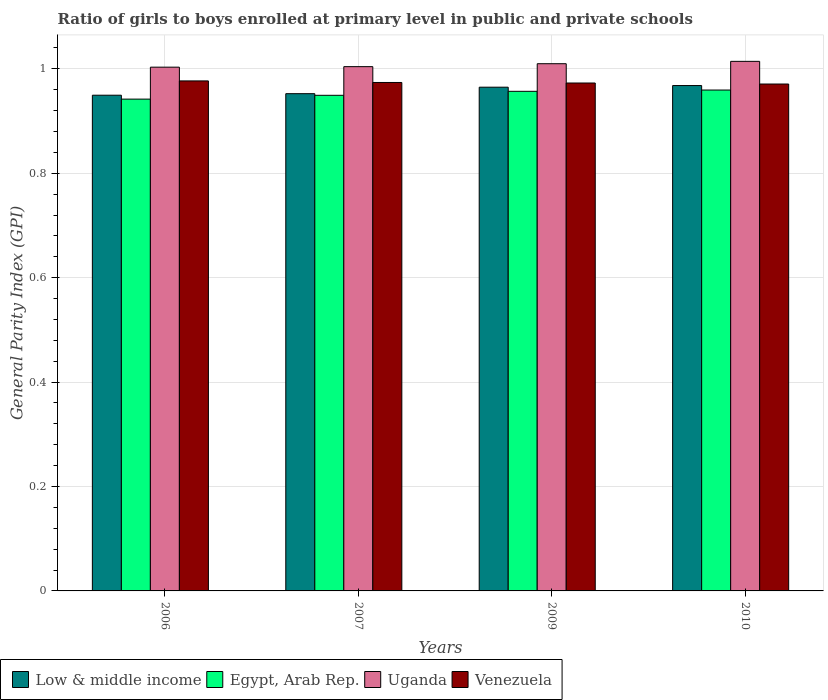How many different coloured bars are there?
Your answer should be compact. 4. Are the number of bars per tick equal to the number of legend labels?
Offer a terse response. Yes. What is the label of the 2nd group of bars from the left?
Offer a very short reply. 2007. What is the general parity index in Egypt, Arab Rep. in 2006?
Keep it short and to the point. 0.94. Across all years, what is the maximum general parity index in Egypt, Arab Rep.?
Ensure brevity in your answer.  0.96. Across all years, what is the minimum general parity index in Venezuela?
Ensure brevity in your answer.  0.97. In which year was the general parity index in Uganda maximum?
Offer a very short reply. 2010. What is the total general parity index in Venezuela in the graph?
Provide a short and direct response. 3.89. What is the difference between the general parity index in Venezuela in 2009 and that in 2010?
Give a very brief answer. 0. What is the difference between the general parity index in Low & middle income in 2010 and the general parity index in Egypt, Arab Rep. in 2006?
Provide a short and direct response. 0.03. What is the average general parity index in Venezuela per year?
Offer a terse response. 0.97. In the year 2010, what is the difference between the general parity index in Low & middle income and general parity index in Uganda?
Your answer should be very brief. -0.05. What is the ratio of the general parity index in Egypt, Arab Rep. in 2007 to that in 2010?
Your answer should be compact. 0.99. Is the general parity index in Low & middle income in 2009 less than that in 2010?
Your response must be concise. Yes. Is the difference between the general parity index in Low & middle income in 2006 and 2010 greater than the difference between the general parity index in Uganda in 2006 and 2010?
Provide a short and direct response. No. What is the difference between the highest and the second highest general parity index in Low & middle income?
Offer a terse response. 0. What is the difference between the highest and the lowest general parity index in Venezuela?
Make the answer very short. 0.01. In how many years, is the general parity index in Egypt, Arab Rep. greater than the average general parity index in Egypt, Arab Rep. taken over all years?
Ensure brevity in your answer.  2. What does the 4th bar from the left in 2006 represents?
Offer a terse response. Venezuela. What does the 2nd bar from the right in 2009 represents?
Your response must be concise. Uganda. How many bars are there?
Make the answer very short. 16. How many years are there in the graph?
Your answer should be compact. 4. What is the difference between two consecutive major ticks on the Y-axis?
Your response must be concise. 0.2. Are the values on the major ticks of Y-axis written in scientific E-notation?
Make the answer very short. No. How many legend labels are there?
Give a very brief answer. 4. What is the title of the graph?
Your response must be concise. Ratio of girls to boys enrolled at primary level in public and private schools. Does "Europe(all income levels)" appear as one of the legend labels in the graph?
Keep it short and to the point. No. What is the label or title of the Y-axis?
Make the answer very short. General Parity Index (GPI). What is the General Parity Index (GPI) in Low & middle income in 2006?
Offer a very short reply. 0.95. What is the General Parity Index (GPI) in Egypt, Arab Rep. in 2006?
Ensure brevity in your answer.  0.94. What is the General Parity Index (GPI) of Uganda in 2006?
Offer a terse response. 1. What is the General Parity Index (GPI) in Venezuela in 2006?
Your answer should be very brief. 0.98. What is the General Parity Index (GPI) of Low & middle income in 2007?
Offer a very short reply. 0.95. What is the General Parity Index (GPI) in Egypt, Arab Rep. in 2007?
Offer a terse response. 0.95. What is the General Parity Index (GPI) in Uganda in 2007?
Ensure brevity in your answer.  1. What is the General Parity Index (GPI) in Venezuela in 2007?
Give a very brief answer. 0.97. What is the General Parity Index (GPI) of Low & middle income in 2009?
Give a very brief answer. 0.96. What is the General Parity Index (GPI) of Egypt, Arab Rep. in 2009?
Your answer should be compact. 0.96. What is the General Parity Index (GPI) in Uganda in 2009?
Your response must be concise. 1.01. What is the General Parity Index (GPI) in Venezuela in 2009?
Make the answer very short. 0.97. What is the General Parity Index (GPI) in Low & middle income in 2010?
Give a very brief answer. 0.97. What is the General Parity Index (GPI) of Egypt, Arab Rep. in 2010?
Offer a very short reply. 0.96. What is the General Parity Index (GPI) in Uganda in 2010?
Provide a succinct answer. 1.01. What is the General Parity Index (GPI) in Venezuela in 2010?
Provide a succinct answer. 0.97. Across all years, what is the maximum General Parity Index (GPI) in Low & middle income?
Ensure brevity in your answer.  0.97. Across all years, what is the maximum General Parity Index (GPI) in Egypt, Arab Rep.?
Offer a terse response. 0.96. Across all years, what is the maximum General Parity Index (GPI) in Uganda?
Your answer should be compact. 1.01. Across all years, what is the maximum General Parity Index (GPI) of Venezuela?
Offer a very short reply. 0.98. Across all years, what is the minimum General Parity Index (GPI) in Low & middle income?
Provide a short and direct response. 0.95. Across all years, what is the minimum General Parity Index (GPI) of Egypt, Arab Rep.?
Offer a terse response. 0.94. Across all years, what is the minimum General Parity Index (GPI) of Uganda?
Give a very brief answer. 1. Across all years, what is the minimum General Parity Index (GPI) in Venezuela?
Make the answer very short. 0.97. What is the total General Parity Index (GPI) in Low & middle income in the graph?
Provide a succinct answer. 3.83. What is the total General Parity Index (GPI) of Egypt, Arab Rep. in the graph?
Keep it short and to the point. 3.81. What is the total General Parity Index (GPI) in Uganda in the graph?
Ensure brevity in your answer.  4.03. What is the total General Parity Index (GPI) of Venezuela in the graph?
Keep it short and to the point. 3.89. What is the difference between the General Parity Index (GPI) of Low & middle income in 2006 and that in 2007?
Ensure brevity in your answer.  -0. What is the difference between the General Parity Index (GPI) of Egypt, Arab Rep. in 2006 and that in 2007?
Your answer should be very brief. -0.01. What is the difference between the General Parity Index (GPI) in Uganda in 2006 and that in 2007?
Keep it short and to the point. -0. What is the difference between the General Parity Index (GPI) of Venezuela in 2006 and that in 2007?
Make the answer very short. 0. What is the difference between the General Parity Index (GPI) of Low & middle income in 2006 and that in 2009?
Make the answer very short. -0.02. What is the difference between the General Parity Index (GPI) of Egypt, Arab Rep. in 2006 and that in 2009?
Make the answer very short. -0.01. What is the difference between the General Parity Index (GPI) in Uganda in 2006 and that in 2009?
Your answer should be compact. -0.01. What is the difference between the General Parity Index (GPI) of Venezuela in 2006 and that in 2009?
Your answer should be very brief. 0. What is the difference between the General Parity Index (GPI) in Low & middle income in 2006 and that in 2010?
Ensure brevity in your answer.  -0.02. What is the difference between the General Parity Index (GPI) of Egypt, Arab Rep. in 2006 and that in 2010?
Provide a succinct answer. -0.02. What is the difference between the General Parity Index (GPI) in Uganda in 2006 and that in 2010?
Provide a succinct answer. -0.01. What is the difference between the General Parity Index (GPI) of Venezuela in 2006 and that in 2010?
Provide a short and direct response. 0.01. What is the difference between the General Parity Index (GPI) in Low & middle income in 2007 and that in 2009?
Make the answer very short. -0.01. What is the difference between the General Parity Index (GPI) in Egypt, Arab Rep. in 2007 and that in 2009?
Your answer should be compact. -0.01. What is the difference between the General Parity Index (GPI) in Uganda in 2007 and that in 2009?
Offer a terse response. -0.01. What is the difference between the General Parity Index (GPI) in Low & middle income in 2007 and that in 2010?
Your answer should be compact. -0.02. What is the difference between the General Parity Index (GPI) of Egypt, Arab Rep. in 2007 and that in 2010?
Offer a very short reply. -0.01. What is the difference between the General Parity Index (GPI) in Uganda in 2007 and that in 2010?
Keep it short and to the point. -0.01. What is the difference between the General Parity Index (GPI) in Venezuela in 2007 and that in 2010?
Provide a succinct answer. 0. What is the difference between the General Parity Index (GPI) of Low & middle income in 2009 and that in 2010?
Provide a succinct answer. -0. What is the difference between the General Parity Index (GPI) in Egypt, Arab Rep. in 2009 and that in 2010?
Make the answer very short. -0. What is the difference between the General Parity Index (GPI) of Uganda in 2009 and that in 2010?
Offer a very short reply. -0. What is the difference between the General Parity Index (GPI) of Venezuela in 2009 and that in 2010?
Offer a very short reply. 0. What is the difference between the General Parity Index (GPI) of Low & middle income in 2006 and the General Parity Index (GPI) of Uganda in 2007?
Offer a terse response. -0.05. What is the difference between the General Parity Index (GPI) of Low & middle income in 2006 and the General Parity Index (GPI) of Venezuela in 2007?
Offer a terse response. -0.02. What is the difference between the General Parity Index (GPI) of Egypt, Arab Rep. in 2006 and the General Parity Index (GPI) of Uganda in 2007?
Make the answer very short. -0.06. What is the difference between the General Parity Index (GPI) in Egypt, Arab Rep. in 2006 and the General Parity Index (GPI) in Venezuela in 2007?
Provide a short and direct response. -0.03. What is the difference between the General Parity Index (GPI) in Uganda in 2006 and the General Parity Index (GPI) in Venezuela in 2007?
Offer a terse response. 0.03. What is the difference between the General Parity Index (GPI) in Low & middle income in 2006 and the General Parity Index (GPI) in Egypt, Arab Rep. in 2009?
Your response must be concise. -0.01. What is the difference between the General Parity Index (GPI) of Low & middle income in 2006 and the General Parity Index (GPI) of Uganda in 2009?
Offer a very short reply. -0.06. What is the difference between the General Parity Index (GPI) of Low & middle income in 2006 and the General Parity Index (GPI) of Venezuela in 2009?
Offer a very short reply. -0.02. What is the difference between the General Parity Index (GPI) in Egypt, Arab Rep. in 2006 and the General Parity Index (GPI) in Uganda in 2009?
Give a very brief answer. -0.07. What is the difference between the General Parity Index (GPI) of Egypt, Arab Rep. in 2006 and the General Parity Index (GPI) of Venezuela in 2009?
Provide a short and direct response. -0.03. What is the difference between the General Parity Index (GPI) of Uganda in 2006 and the General Parity Index (GPI) of Venezuela in 2009?
Your response must be concise. 0.03. What is the difference between the General Parity Index (GPI) in Low & middle income in 2006 and the General Parity Index (GPI) in Egypt, Arab Rep. in 2010?
Your answer should be compact. -0.01. What is the difference between the General Parity Index (GPI) in Low & middle income in 2006 and the General Parity Index (GPI) in Uganda in 2010?
Your answer should be compact. -0.06. What is the difference between the General Parity Index (GPI) of Low & middle income in 2006 and the General Parity Index (GPI) of Venezuela in 2010?
Make the answer very short. -0.02. What is the difference between the General Parity Index (GPI) in Egypt, Arab Rep. in 2006 and the General Parity Index (GPI) in Uganda in 2010?
Your answer should be very brief. -0.07. What is the difference between the General Parity Index (GPI) in Egypt, Arab Rep. in 2006 and the General Parity Index (GPI) in Venezuela in 2010?
Provide a succinct answer. -0.03. What is the difference between the General Parity Index (GPI) in Uganda in 2006 and the General Parity Index (GPI) in Venezuela in 2010?
Provide a succinct answer. 0.03. What is the difference between the General Parity Index (GPI) of Low & middle income in 2007 and the General Parity Index (GPI) of Egypt, Arab Rep. in 2009?
Give a very brief answer. -0. What is the difference between the General Parity Index (GPI) of Low & middle income in 2007 and the General Parity Index (GPI) of Uganda in 2009?
Your response must be concise. -0.06. What is the difference between the General Parity Index (GPI) of Low & middle income in 2007 and the General Parity Index (GPI) of Venezuela in 2009?
Offer a very short reply. -0.02. What is the difference between the General Parity Index (GPI) of Egypt, Arab Rep. in 2007 and the General Parity Index (GPI) of Uganda in 2009?
Offer a very short reply. -0.06. What is the difference between the General Parity Index (GPI) of Egypt, Arab Rep. in 2007 and the General Parity Index (GPI) of Venezuela in 2009?
Offer a very short reply. -0.02. What is the difference between the General Parity Index (GPI) in Uganda in 2007 and the General Parity Index (GPI) in Venezuela in 2009?
Make the answer very short. 0.03. What is the difference between the General Parity Index (GPI) of Low & middle income in 2007 and the General Parity Index (GPI) of Egypt, Arab Rep. in 2010?
Your answer should be very brief. -0.01. What is the difference between the General Parity Index (GPI) in Low & middle income in 2007 and the General Parity Index (GPI) in Uganda in 2010?
Give a very brief answer. -0.06. What is the difference between the General Parity Index (GPI) of Low & middle income in 2007 and the General Parity Index (GPI) of Venezuela in 2010?
Make the answer very short. -0.02. What is the difference between the General Parity Index (GPI) of Egypt, Arab Rep. in 2007 and the General Parity Index (GPI) of Uganda in 2010?
Your answer should be very brief. -0.07. What is the difference between the General Parity Index (GPI) in Egypt, Arab Rep. in 2007 and the General Parity Index (GPI) in Venezuela in 2010?
Your answer should be compact. -0.02. What is the difference between the General Parity Index (GPI) of Low & middle income in 2009 and the General Parity Index (GPI) of Egypt, Arab Rep. in 2010?
Provide a succinct answer. 0.01. What is the difference between the General Parity Index (GPI) of Low & middle income in 2009 and the General Parity Index (GPI) of Uganda in 2010?
Offer a very short reply. -0.05. What is the difference between the General Parity Index (GPI) of Low & middle income in 2009 and the General Parity Index (GPI) of Venezuela in 2010?
Provide a succinct answer. -0.01. What is the difference between the General Parity Index (GPI) in Egypt, Arab Rep. in 2009 and the General Parity Index (GPI) in Uganda in 2010?
Keep it short and to the point. -0.06. What is the difference between the General Parity Index (GPI) of Egypt, Arab Rep. in 2009 and the General Parity Index (GPI) of Venezuela in 2010?
Your answer should be very brief. -0.01. What is the difference between the General Parity Index (GPI) in Uganda in 2009 and the General Parity Index (GPI) in Venezuela in 2010?
Make the answer very short. 0.04. What is the average General Parity Index (GPI) in Low & middle income per year?
Give a very brief answer. 0.96. What is the average General Parity Index (GPI) of Egypt, Arab Rep. per year?
Give a very brief answer. 0.95. What is the average General Parity Index (GPI) of Uganda per year?
Your answer should be very brief. 1.01. What is the average General Parity Index (GPI) of Venezuela per year?
Offer a very short reply. 0.97. In the year 2006, what is the difference between the General Parity Index (GPI) of Low & middle income and General Parity Index (GPI) of Egypt, Arab Rep.?
Give a very brief answer. 0.01. In the year 2006, what is the difference between the General Parity Index (GPI) of Low & middle income and General Parity Index (GPI) of Uganda?
Provide a short and direct response. -0.05. In the year 2006, what is the difference between the General Parity Index (GPI) in Low & middle income and General Parity Index (GPI) in Venezuela?
Your answer should be very brief. -0.03. In the year 2006, what is the difference between the General Parity Index (GPI) in Egypt, Arab Rep. and General Parity Index (GPI) in Uganda?
Ensure brevity in your answer.  -0.06. In the year 2006, what is the difference between the General Parity Index (GPI) in Egypt, Arab Rep. and General Parity Index (GPI) in Venezuela?
Provide a succinct answer. -0.03. In the year 2006, what is the difference between the General Parity Index (GPI) of Uganda and General Parity Index (GPI) of Venezuela?
Keep it short and to the point. 0.03. In the year 2007, what is the difference between the General Parity Index (GPI) of Low & middle income and General Parity Index (GPI) of Egypt, Arab Rep.?
Offer a terse response. 0. In the year 2007, what is the difference between the General Parity Index (GPI) in Low & middle income and General Parity Index (GPI) in Uganda?
Provide a succinct answer. -0.05. In the year 2007, what is the difference between the General Parity Index (GPI) in Low & middle income and General Parity Index (GPI) in Venezuela?
Your response must be concise. -0.02. In the year 2007, what is the difference between the General Parity Index (GPI) in Egypt, Arab Rep. and General Parity Index (GPI) in Uganda?
Keep it short and to the point. -0.05. In the year 2007, what is the difference between the General Parity Index (GPI) in Egypt, Arab Rep. and General Parity Index (GPI) in Venezuela?
Your response must be concise. -0.02. In the year 2007, what is the difference between the General Parity Index (GPI) of Uganda and General Parity Index (GPI) of Venezuela?
Offer a terse response. 0.03. In the year 2009, what is the difference between the General Parity Index (GPI) of Low & middle income and General Parity Index (GPI) of Egypt, Arab Rep.?
Keep it short and to the point. 0.01. In the year 2009, what is the difference between the General Parity Index (GPI) of Low & middle income and General Parity Index (GPI) of Uganda?
Offer a terse response. -0.04. In the year 2009, what is the difference between the General Parity Index (GPI) in Low & middle income and General Parity Index (GPI) in Venezuela?
Give a very brief answer. -0.01. In the year 2009, what is the difference between the General Parity Index (GPI) in Egypt, Arab Rep. and General Parity Index (GPI) in Uganda?
Your answer should be compact. -0.05. In the year 2009, what is the difference between the General Parity Index (GPI) in Egypt, Arab Rep. and General Parity Index (GPI) in Venezuela?
Offer a very short reply. -0.02. In the year 2009, what is the difference between the General Parity Index (GPI) in Uganda and General Parity Index (GPI) in Venezuela?
Keep it short and to the point. 0.04. In the year 2010, what is the difference between the General Parity Index (GPI) in Low & middle income and General Parity Index (GPI) in Egypt, Arab Rep.?
Provide a succinct answer. 0.01. In the year 2010, what is the difference between the General Parity Index (GPI) of Low & middle income and General Parity Index (GPI) of Uganda?
Your response must be concise. -0.05. In the year 2010, what is the difference between the General Parity Index (GPI) of Low & middle income and General Parity Index (GPI) of Venezuela?
Provide a short and direct response. -0. In the year 2010, what is the difference between the General Parity Index (GPI) in Egypt, Arab Rep. and General Parity Index (GPI) in Uganda?
Keep it short and to the point. -0.05. In the year 2010, what is the difference between the General Parity Index (GPI) of Egypt, Arab Rep. and General Parity Index (GPI) of Venezuela?
Offer a terse response. -0.01. In the year 2010, what is the difference between the General Parity Index (GPI) of Uganda and General Parity Index (GPI) of Venezuela?
Provide a succinct answer. 0.04. What is the ratio of the General Parity Index (GPI) of Low & middle income in 2006 to that in 2007?
Provide a short and direct response. 1. What is the ratio of the General Parity Index (GPI) in Egypt, Arab Rep. in 2006 to that in 2007?
Provide a short and direct response. 0.99. What is the ratio of the General Parity Index (GPI) in Low & middle income in 2006 to that in 2009?
Provide a succinct answer. 0.98. What is the ratio of the General Parity Index (GPI) of Egypt, Arab Rep. in 2006 to that in 2009?
Your answer should be very brief. 0.98. What is the ratio of the General Parity Index (GPI) in Venezuela in 2006 to that in 2009?
Keep it short and to the point. 1. What is the ratio of the General Parity Index (GPI) in Low & middle income in 2006 to that in 2010?
Provide a succinct answer. 0.98. What is the ratio of the General Parity Index (GPI) of Egypt, Arab Rep. in 2006 to that in 2010?
Give a very brief answer. 0.98. What is the ratio of the General Parity Index (GPI) in Venezuela in 2006 to that in 2010?
Provide a short and direct response. 1.01. What is the ratio of the General Parity Index (GPI) of Low & middle income in 2007 to that in 2009?
Give a very brief answer. 0.99. What is the ratio of the General Parity Index (GPI) of Uganda in 2007 to that in 2009?
Make the answer very short. 0.99. What is the ratio of the General Parity Index (GPI) in Venezuela in 2007 to that in 2009?
Ensure brevity in your answer.  1. What is the ratio of the General Parity Index (GPI) in Low & middle income in 2007 to that in 2010?
Your response must be concise. 0.98. What is the ratio of the General Parity Index (GPI) in Egypt, Arab Rep. in 2007 to that in 2010?
Your response must be concise. 0.99. What is the ratio of the General Parity Index (GPI) in Uganda in 2007 to that in 2010?
Make the answer very short. 0.99. What is the ratio of the General Parity Index (GPI) of Venezuela in 2007 to that in 2010?
Your response must be concise. 1. What is the ratio of the General Parity Index (GPI) of Uganda in 2009 to that in 2010?
Your answer should be compact. 1. What is the ratio of the General Parity Index (GPI) in Venezuela in 2009 to that in 2010?
Your response must be concise. 1. What is the difference between the highest and the second highest General Parity Index (GPI) of Low & middle income?
Provide a short and direct response. 0. What is the difference between the highest and the second highest General Parity Index (GPI) in Egypt, Arab Rep.?
Offer a terse response. 0. What is the difference between the highest and the second highest General Parity Index (GPI) of Uganda?
Ensure brevity in your answer.  0. What is the difference between the highest and the second highest General Parity Index (GPI) in Venezuela?
Give a very brief answer. 0. What is the difference between the highest and the lowest General Parity Index (GPI) in Low & middle income?
Keep it short and to the point. 0.02. What is the difference between the highest and the lowest General Parity Index (GPI) in Egypt, Arab Rep.?
Your answer should be very brief. 0.02. What is the difference between the highest and the lowest General Parity Index (GPI) of Uganda?
Your response must be concise. 0.01. What is the difference between the highest and the lowest General Parity Index (GPI) of Venezuela?
Your answer should be very brief. 0.01. 